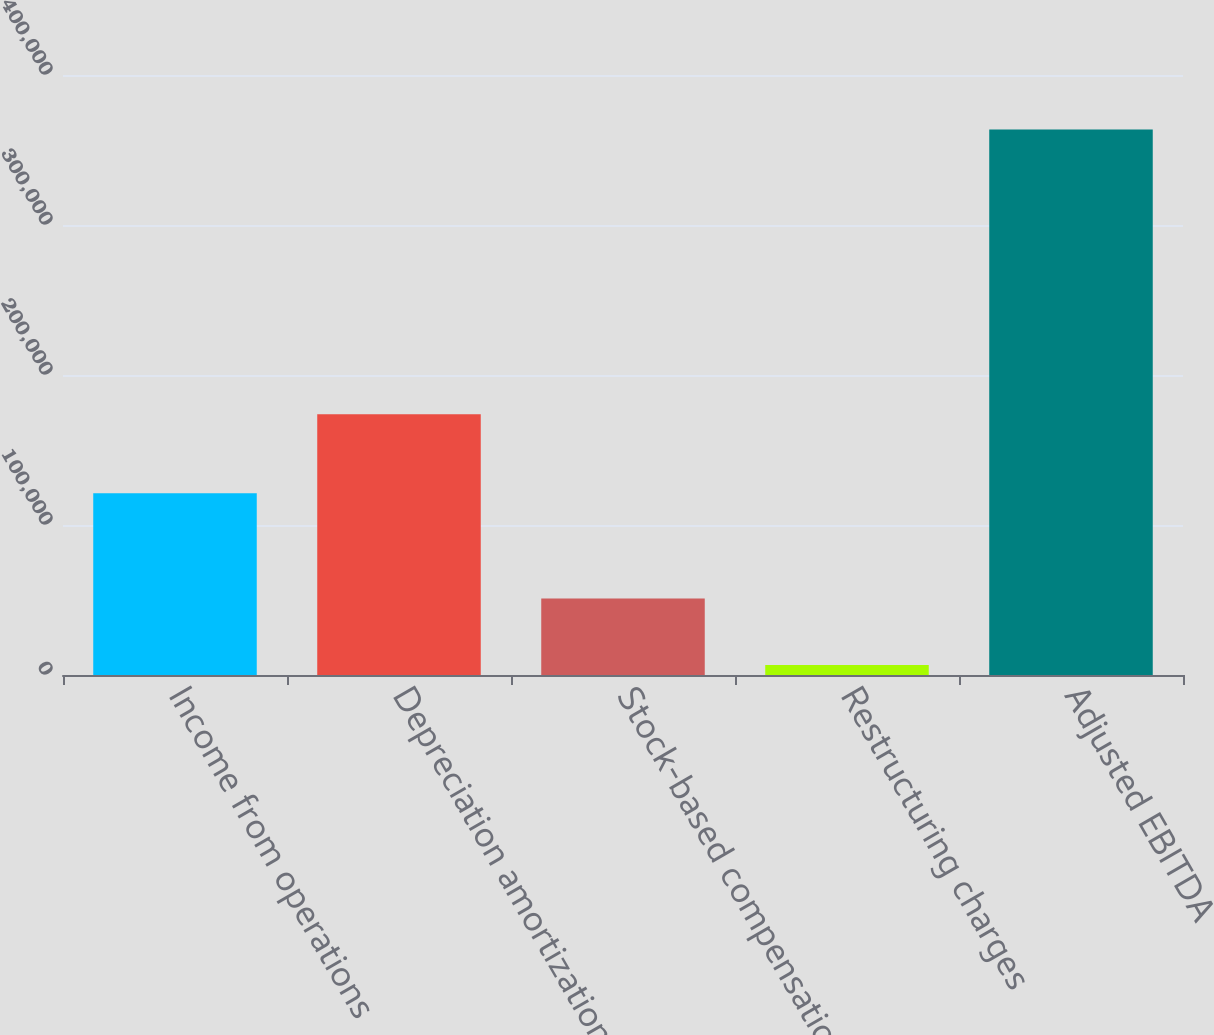Convert chart. <chart><loc_0><loc_0><loc_500><loc_500><bar_chart><fcel>Income from operations<fcel>Depreciation amortization and<fcel>Stock-based compensation<fcel>Restructuring charges<fcel>Adjusted EBITDA<nl><fcel>121118<fcel>173811<fcel>50966<fcel>6734<fcel>363723<nl></chart> 